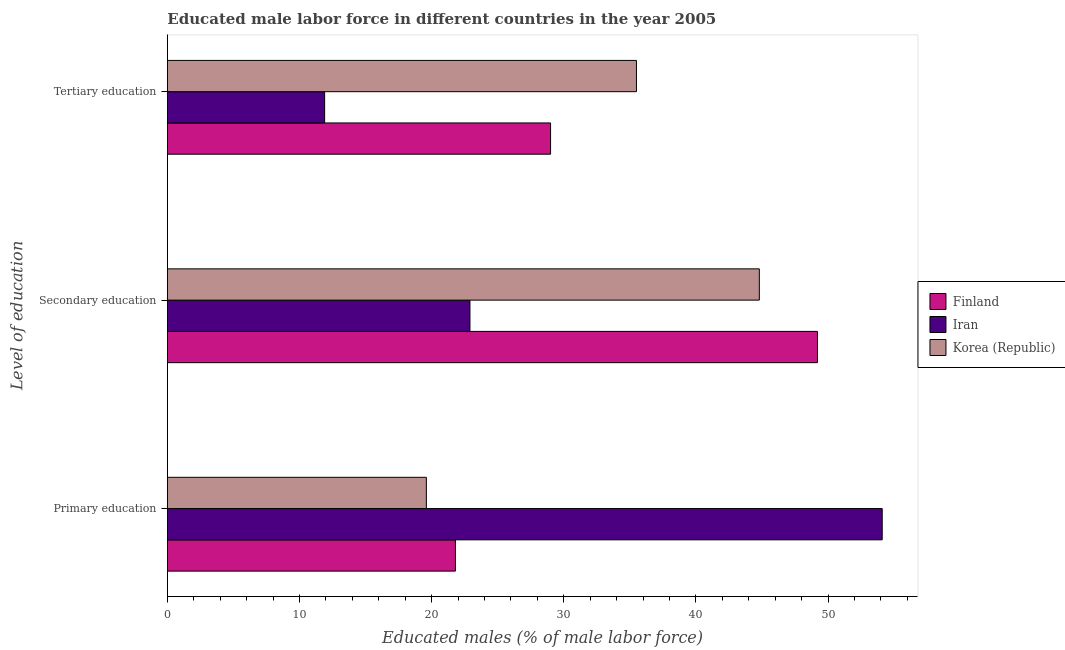How many different coloured bars are there?
Make the answer very short. 3. Are the number of bars per tick equal to the number of legend labels?
Offer a terse response. Yes. What is the label of the 2nd group of bars from the top?
Offer a very short reply. Secondary education. What is the percentage of male labor force who received secondary education in Iran?
Keep it short and to the point. 22.9. Across all countries, what is the maximum percentage of male labor force who received secondary education?
Your answer should be very brief. 49.2. Across all countries, what is the minimum percentage of male labor force who received secondary education?
Ensure brevity in your answer.  22.9. In which country was the percentage of male labor force who received primary education maximum?
Offer a terse response. Iran. In which country was the percentage of male labor force who received tertiary education minimum?
Give a very brief answer. Iran. What is the total percentage of male labor force who received tertiary education in the graph?
Offer a very short reply. 76.4. What is the difference between the percentage of male labor force who received tertiary education in Iran and that in Korea (Republic)?
Make the answer very short. -23.6. What is the difference between the percentage of male labor force who received primary education in Finland and the percentage of male labor force who received tertiary education in Iran?
Offer a very short reply. 9.9. What is the average percentage of male labor force who received primary education per country?
Keep it short and to the point. 31.83. What is the difference between the percentage of male labor force who received tertiary education and percentage of male labor force who received secondary education in Korea (Republic)?
Give a very brief answer. -9.3. In how many countries, is the percentage of male labor force who received secondary education greater than 20 %?
Give a very brief answer. 3. What is the ratio of the percentage of male labor force who received secondary education in Iran to that in Finland?
Your answer should be compact. 0.47. Is the percentage of male labor force who received primary education in Iran less than that in Korea (Republic)?
Provide a short and direct response. No. What is the difference between the highest and the second highest percentage of male labor force who received primary education?
Offer a very short reply. 32.3. What is the difference between the highest and the lowest percentage of male labor force who received primary education?
Your answer should be compact. 34.5. What does the 1st bar from the top in Tertiary education represents?
Provide a short and direct response. Korea (Republic). What does the 2nd bar from the bottom in Secondary education represents?
Provide a short and direct response. Iran. How many bars are there?
Provide a succinct answer. 9. How many countries are there in the graph?
Provide a short and direct response. 3. Does the graph contain any zero values?
Offer a very short reply. No. Where does the legend appear in the graph?
Keep it short and to the point. Center right. How many legend labels are there?
Your response must be concise. 3. How are the legend labels stacked?
Keep it short and to the point. Vertical. What is the title of the graph?
Your answer should be compact. Educated male labor force in different countries in the year 2005. Does "Algeria" appear as one of the legend labels in the graph?
Your answer should be very brief. No. What is the label or title of the X-axis?
Provide a succinct answer. Educated males (% of male labor force). What is the label or title of the Y-axis?
Provide a short and direct response. Level of education. What is the Educated males (% of male labor force) of Finland in Primary education?
Ensure brevity in your answer.  21.8. What is the Educated males (% of male labor force) of Iran in Primary education?
Your answer should be very brief. 54.1. What is the Educated males (% of male labor force) in Korea (Republic) in Primary education?
Ensure brevity in your answer.  19.6. What is the Educated males (% of male labor force) of Finland in Secondary education?
Provide a succinct answer. 49.2. What is the Educated males (% of male labor force) in Iran in Secondary education?
Provide a succinct answer. 22.9. What is the Educated males (% of male labor force) of Korea (Republic) in Secondary education?
Give a very brief answer. 44.8. What is the Educated males (% of male labor force) in Iran in Tertiary education?
Your answer should be very brief. 11.9. What is the Educated males (% of male labor force) in Korea (Republic) in Tertiary education?
Give a very brief answer. 35.5. Across all Level of education, what is the maximum Educated males (% of male labor force) of Finland?
Offer a very short reply. 49.2. Across all Level of education, what is the maximum Educated males (% of male labor force) in Iran?
Your response must be concise. 54.1. Across all Level of education, what is the maximum Educated males (% of male labor force) of Korea (Republic)?
Your answer should be very brief. 44.8. Across all Level of education, what is the minimum Educated males (% of male labor force) of Finland?
Keep it short and to the point. 21.8. Across all Level of education, what is the minimum Educated males (% of male labor force) in Iran?
Your response must be concise. 11.9. Across all Level of education, what is the minimum Educated males (% of male labor force) in Korea (Republic)?
Your answer should be compact. 19.6. What is the total Educated males (% of male labor force) in Iran in the graph?
Provide a short and direct response. 88.9. What is the total Educated males (% of male labor force) of Korea (Republic) in the graph?
Provide a short and direct response. 99.9. What is the difference between the Educated males (% of male labor force) of Finland in Primary education and that in Secondary education?
Give a very brief answer. -27.4. What is the difference between the Educated males (% of male labor force) in Iran in Primary education and that in Secondary education?
Offer a terse response. 31.2. What is the difference between the Educated males (% of male labor force) in Korea (Republic) in Primary education and that in Secondary education?
Ensure brevity in your answer.  -25.2. What is the difference between the Educated males (% of male labor force) of Iran in Primary education and that in Tertiary education?
Your answer should be compact. 42.2. What is the difference between the Educated males (% of male labor force) of Korea (Republic) in Primary education and that in Tertiary education?
Provide a succinct answer. -15.9. What is the difference between the Educated males (% of male labor force) in Finland in Secondary education and that in Tertiary education?
Provide a succinct answer. 20.2. What is the difference between the Educated males (% of male labor force) in Iran in Secondary education and that in Tertiary education?
Provide a short and direct response. 11. What is the difference between the Educated males (% of male labor force) in Finland in Primary education and the Educated males (% of male labor force) in Korea (Republic) in Secondary education?
Offer a very short reply. -23. What is the difference between the Educated males (% of male labor force) in Iran in Primary education and the Educated males (% of male labor force) in Korea (Republic) in Secondary education?
Provide a succinct answer. 9.3. What is the difference between the Educated males (% of male labor force) in Finland in Primary education and the Educated males (% of male labor force) in Iran in Tertiary education?
Provide a short and direct response. 9.9. What is the difference between the Educated males (% of male labor force) of Finland in Primary education and the Educated males (% of male labor force) of Korea (Republic) in Tertiary education?
Offer a very short reply. -13.7. What is the difference between the Educated males (% of male labor force) in Finland in Secondary education and the Educated males (% of male labor force) in Iran in Tertiary education?
Keep it short and to the point. 37.3. What is the difference between the Educated males (% of male labor force) of Finland in Secondary education and the Educated males (% of male labor force) of Korea (Republic) in Tertiary education?
Provide a succinct answer. 13.7. What is the average Educated males (% of male labor force) of Finland per Level of education?
Your response must be concise. 33.33. What is the average Educated males (% of male labor force) of Iran per Level of education?
Make the answer very short. 29.63. What is the average Educated males (% of male labor force) in Korea (Republic) per Level of education?
Your response must be concise. 33.3. What is the difference between the Educated males (% of male labor force) of Finland and Educated males (% of male labor force) of Iran in Primary education?
Keep it short and to the point. -32.3. What is the difference between the Educated males (% of male labor force) of Finland and Educated males (% of male labor force) of Korea (Republic) in Primary education?
Ensure brevity in your answer.  2.2. What is the difference between the Educated males (% of male labor force) of Iran and Educated males (% of male labor force) of Korea (Republic) in Primary education?
Offer a very short reply. 34.5. What is the difference between the Educated males (% of male labor force) in Finland and Educated males (% of male labor force) in Iran in Secondary education?
Offer a terse response. 26.3. What is the difference between the Educated males (% of male labor force) in Finland and Educated males (% of male labor force) in Korea (Republic) in Secondary education?
Keep it short and to the point. 4.4. What is the difference between the Educated males (% of male labor force) of Iran and Educated males (% of male labor force) of Korea (Republic) in Secondary education?
Your response must be concise. -21.9. What is the difference between the Educated males (% of male labor force) in Finland and Educated males (% of male labor force) in Iran in Tertiary education?
Provide a short and direct response. 17.1. What is the difference between the Educated males (% of male labor force) of Iran and Educated males (% of male labor force) of Korea (Republic) in Tertiary education?
Make the answer very short. -23.6. What is the ratio of the Educated males (% of male labor force) in Finland in Primary education to that in Secondary education?
Your response must be concise. 0.44. What is the ratio of the Educated males (% of male labor force) of Iran in Primary education to that in Secondary education?
Offer a very short reply. 2.36. What is the ratio of the Educated males (% of male labor force) of Korea (Republic) in Primary education to that in Secondary education?
Your answer should be very brief. 0.44. What is the ratio of the Educated males (% of male labor force) in Finland in Primary education to that in Tertiary education?
Ensure brevity in your answer.  0.75. What is the ratio of the Educated males (% of male labor force) of Iran in Primary education to that in Tertiary education?
Provide a short and direct response. 4.55. What is the ratio of the Educated males (% of male labor force) in Korea (Republic) in Primary education to that in Tertiary education?
Offer a very short reply. 0.55. What is the ratio of the Educated males (% of male labor force) of Finland in Secondary education to that in Tertiary education?
Your answer should be very brief. 1.7. What is the ratio of the Educated males (% of male labor force) in Iran in Secondary education to that in Tertiary education?
Make the answer very short. 1.92. What is the ratio of the Educated males (% of male labor force) of Korea (Republic) in Secondary education to that in Tertiary education?
Offer a terse response. 1.26. What is the difference between the highest and the second highest Educated males (% of male labor force) in Finland?
Ensure brevity in your answer.  20.2. What is the difference between the highest and the second highest Educated males (% of male labor force) in Iran?
Make the answer very short. 31.2. What is the difference between the highest and the lowest Educated males (% of male labor force) of Finland?
Your response must be concise. 27.4. What is the difference between the highest and the lowest Educated males (% of male labor force) in Iran?
Offer a terse response. 42.2. What is the difference between the highest and the lowest Educated males (% of male labor force) of Korea (Republic)?
Offer a very short reply. 25.2. 